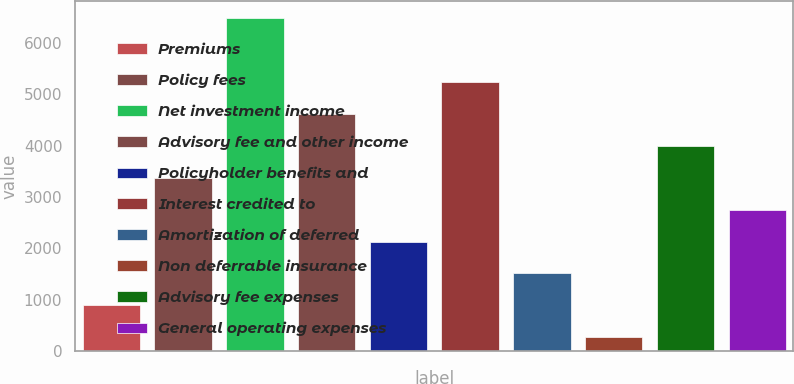Convert chart. <chart><loc_0><loc_0><loc_500><loc_500><bar_chart><fcel>Premiums<fcel>Policy fees<fcel>Net investment income<fcel>Advisory fee and other income<fcel>Policyholder benefits and<fcel>Interest credited to<fcel>Amortization of deferred<fcel>Non deferrable insurance<fcel>Advisory fee expenses<fcel>General operating expenses<nl><fcel>887.4<fcel>3377<fcel>6489<fcel>4621.8<fcel>2132.2<fcel>5244.2<fcel>1509.8<fcel>265<fcel>3999.4<fcel>2754.6<nl></chart> 